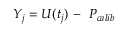Convert formula to latex. <formula><loc_0><loc_0><loc_500><loc_500>Y _ { j } = U ( t _ { j } ) \, - \ P _ { c a l i b }</formula> 